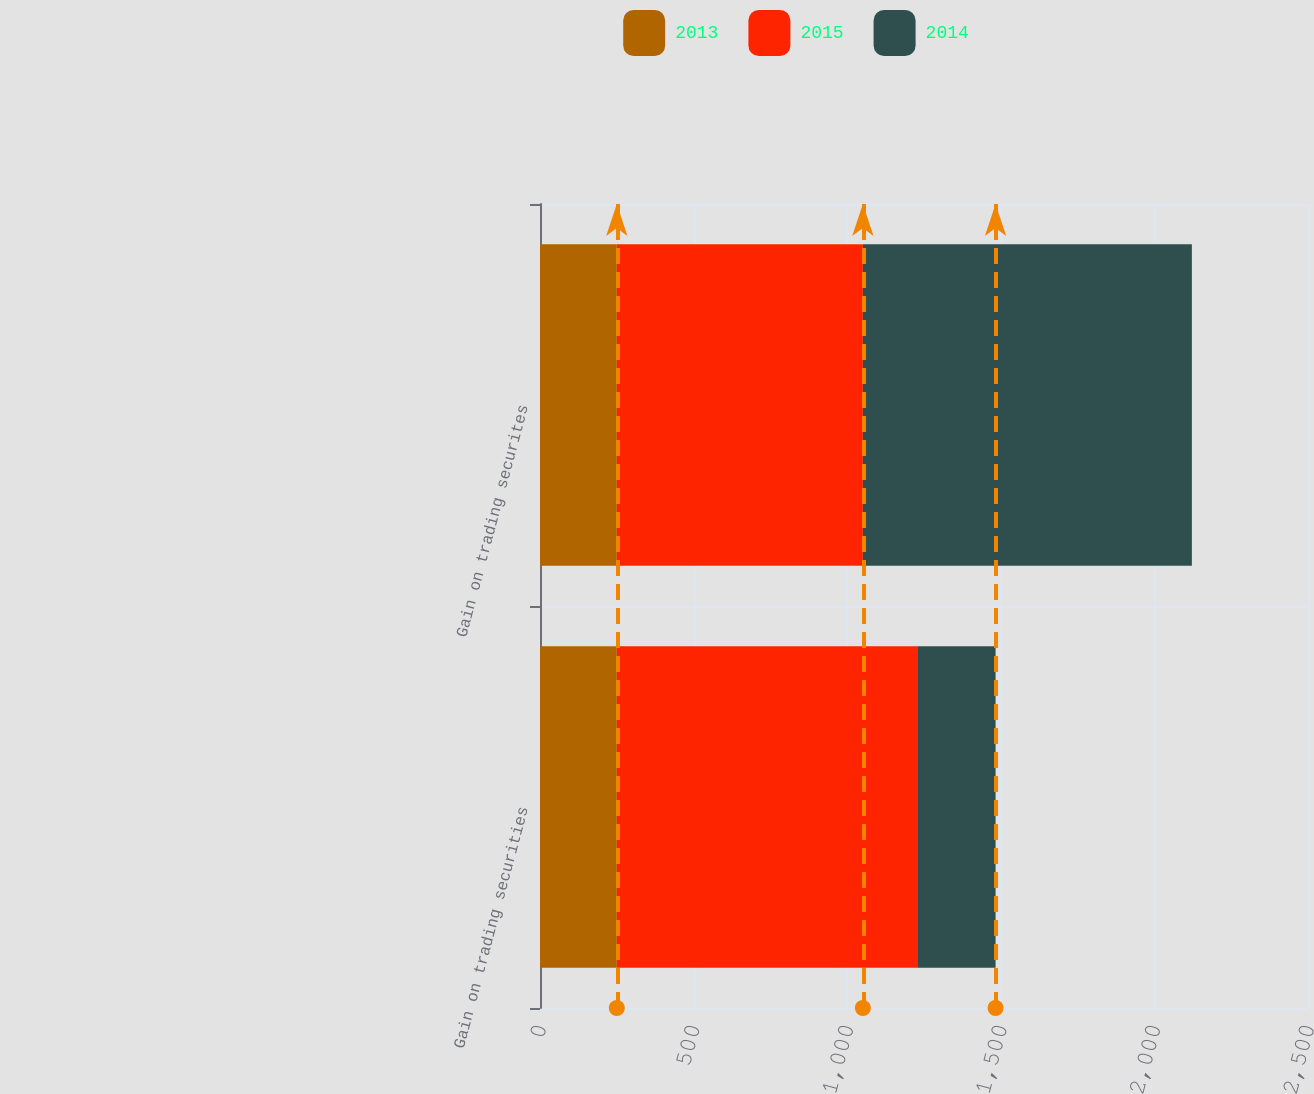Convert chart to OTSL. <chart><loc_0><loc_0><loc_500><loc_500><stacked_bar_chart><ecel><fcel>Gain on trading securities<fcel>Gain on trading securites<nl><fcel>2013<fcel>250<fcel>250<nl><fcel>2015<fcel>978<fcel>801<nl><fcel>2014<fcel>255<fcel>1071<nl></chart> 